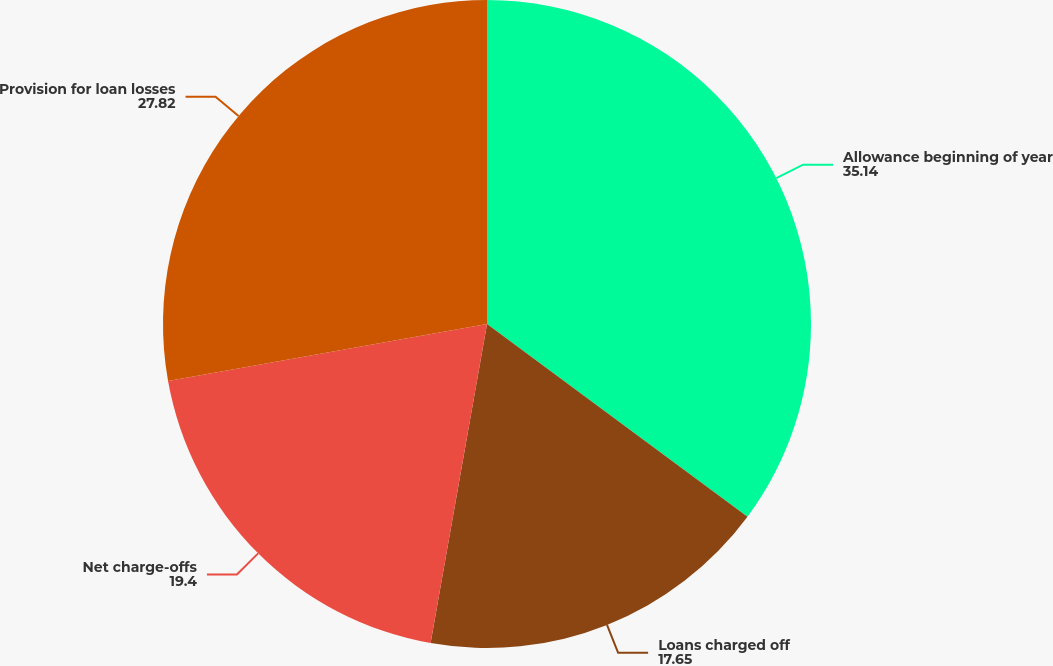Convert chart. <chart><loc_0><loc_0><loc_500><loc_500><pie_chart><fcel>Allowance beginning of year<fcel>Loans charged off<fcel>Net charge-offs<fcel>Provision for loan losses<nl><fcel>35.14%<fcel>17.65%<fcel>19.4%<fcel>27.82%<nl></chart> 